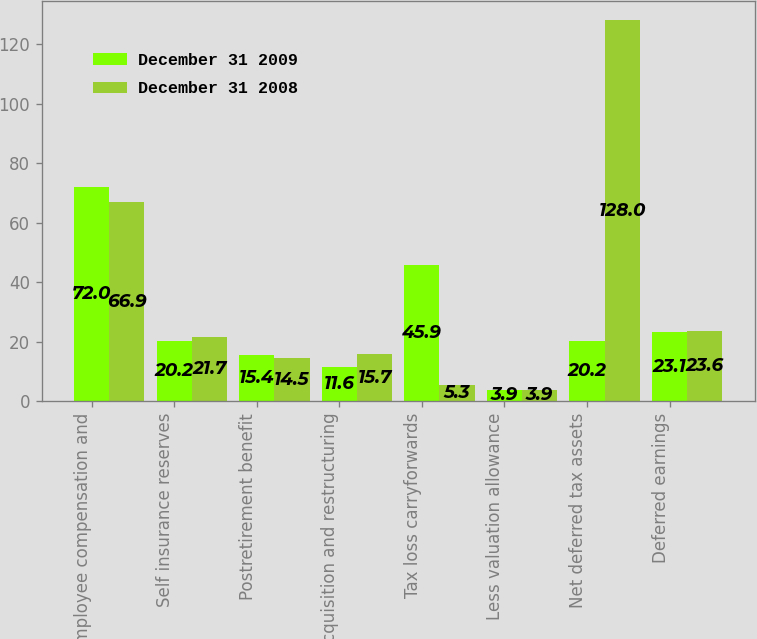Convert chart. <chart><loc_0><loc_0><loc_500><loc_500><stacked_bar_chart><ecel><fcel>Employee compensation and<fcel>Self insurance reserves<fcel>Postretirement benefit<fcel>Acquisition and restructuring<fcel>Tax loss carryforwards<fcel>Less valuation allowance<fcel>Net deferred tax assets<fcel>Deferred earnings<nl><fcel>December 31 2009<fcel>72<fcel>20.2<fcel>15.4<fcel>11.6<fcel>45.9<fcel>3.9<fcel>20.2<fcel>23.1<nl><fcel>December 31 2008<fcel>66.9<fcel>21.7<fcel>14.5<fcel>15.7<fcel>5.3<fcel>3.9<fcel>128<fcel>23.6<nl></chart> 